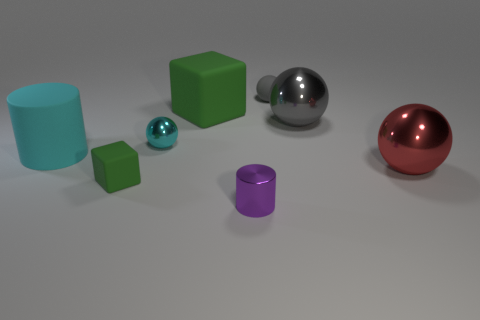Add 1 small metallic cylinders. How many objects exist? 9 Subtract all cyan balls. How many balls are left? 3 Subtract all cubes. How many objects are left? 6 Subtract all gray blocks. How many gray spheres are left? 2 Subtract all cyan spheres. How many spheres are left? 3 Subtract 1 cubes. How many cubes are left? 1 Subtract all blue balls. Subtract all red cylinders. How many balls are left? 4 Subtract all small yellow metal cubes. Subtract all big objects. How many objects are left? 4 Add 2 red spheres. How many red spheres are left? 3 Add 4 tiny red spheres. How many tiny red spheres exist? 4 